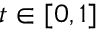Convert formula to latex. <formula><loc_0><loc_0><loc_500><loc_500>t \in [ 0 , 1 ]</formula> 